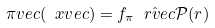Convert formula to latex. <formula><loc_0><loc_0><loc_500><loc_500>\pi v e c ( \ x v e c ) = f _ { \pi } \hat { \ r v e c } \mathcal { P } ( r )</formula> 